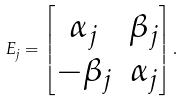<formula> <loc_0><loc_0><loc_500><loc_500>E _ { j } = \left [ \begin{matrix} \alpha _ { j } & \beta _ { j } \\ - \beta _ { j } & \alpha _ { j } \\ \end{matrix} \right ] .</formula> 